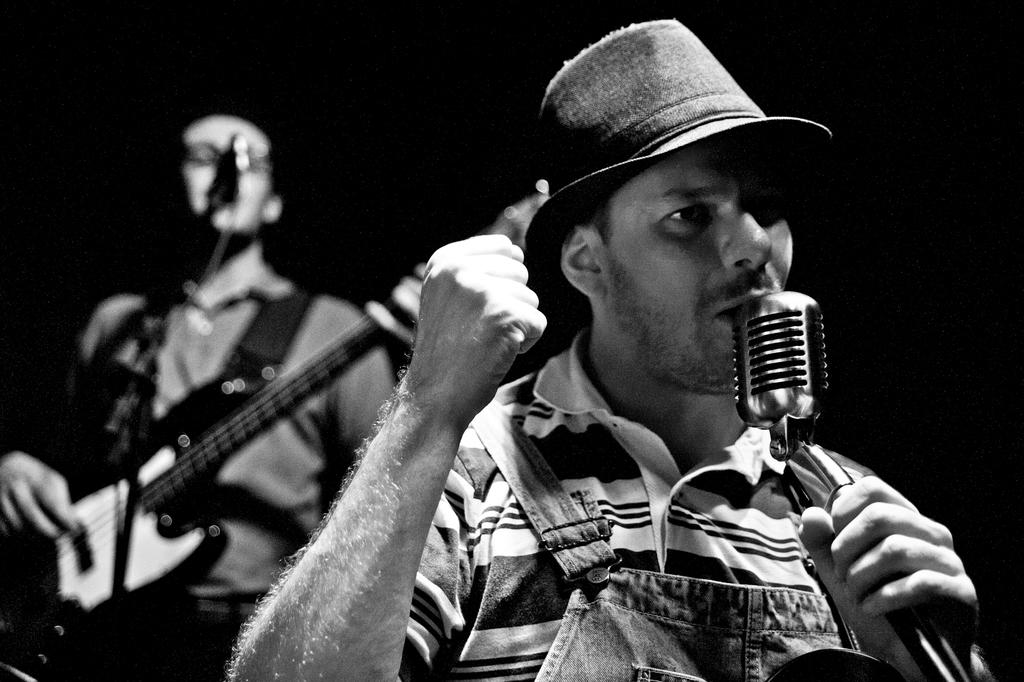How many people are in the image? There are two persons in the image. What are the persons doing in the image? The persons are standing and singing. Can you describe any specific actions or objects related to the persons? One person is holding a microphone, and one person is playing a guitar. Is there any headwear visible on any of the persons? Yes, one person is wearing a cap. What type of teeth can be seen in the image? There are no teeth visible in the image. 